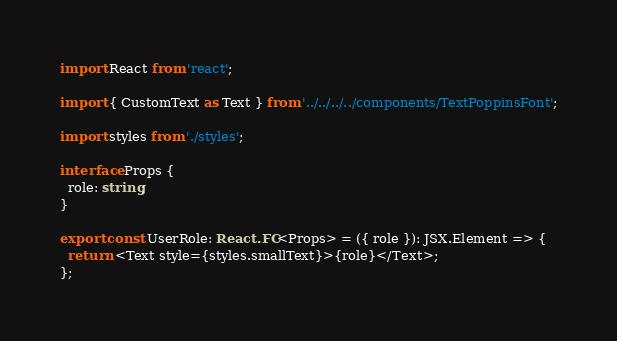<code> <loc_0><loc_0><loc_500><loc_500><_TypeScript_>import React from 'react';

import { CustomText as Text } from '../../../../components/TextPoppinsFont';

import styles from './styles';

interface Props {
  role: string;
}

export const UserRole: React.FC<Props> = ({ role }): JSX.Element => {
  return <Text style={styles.smallText}>{role}</Text>;
};
</code> 